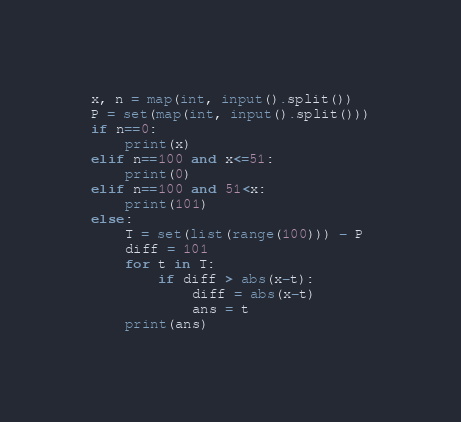<code> <loc_0><loc_0><loc_500><loc_500><_Python_>x, n = map(int, input().split())
P = set(map(int, input().split()))
if n==0:
    print(x)
elif n==100 and x<=51:
    print(0)
elif n==100 and 51<x:
    print(101)
else:
    T = set(list(range(100))) - P
    diff = 101
    for t in T:
        if diff > abs(x-t):
            diff = abs(x-t)
            ans = t
    print(ans)</code> 